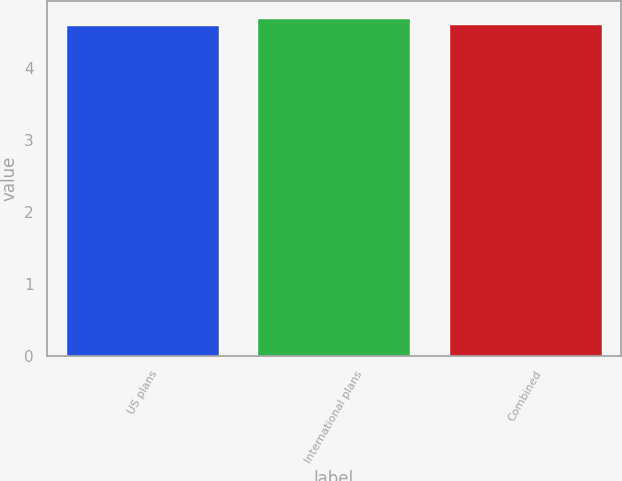Convert chart. <chart><loc_0><loc_0><loc_500><loc_500><bar_chart><fcel>US plans<fcel>International plans<fcel>Combined<nl><fcel>4.6<fcel>4.7<fcel>4.61<nl></chart> 